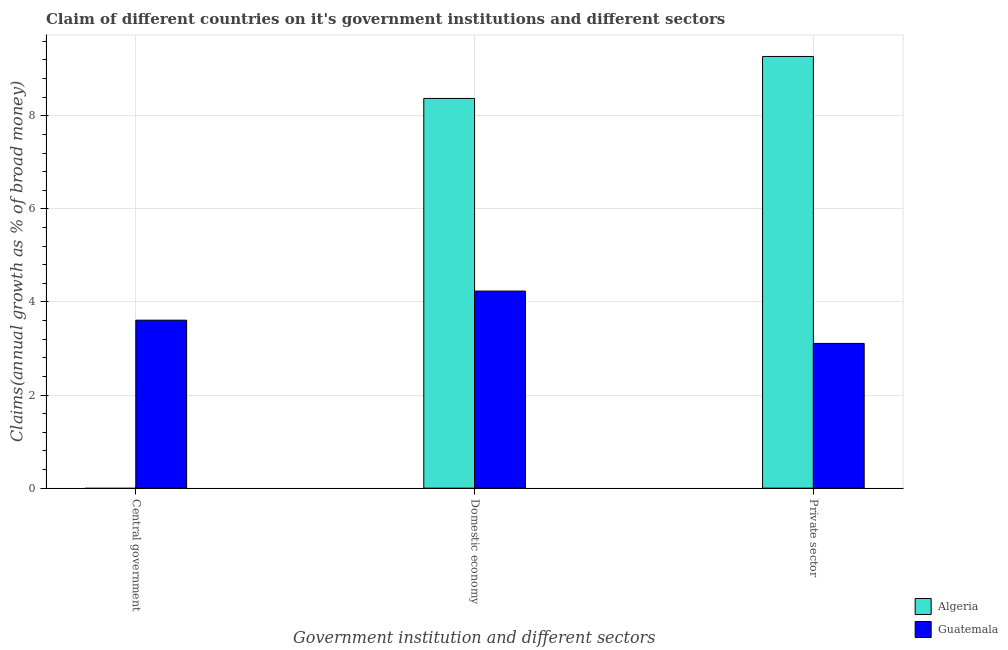Are the number of bars per tick equal to the number of legend labels?
Your answer should be compact. No. Are the number of bars on each tick of the X-axis equal?
Your answer should be compact. No. What is the label of the 1st group of bars from the left?
Give a very brief answer. Central government. What is the percentage of claim on the private sector in Guatemala?
Ensure brevity in your answer.  3.11. Across all countries, what is the maximum percentage of claim on the domestic economy?
Keep it short and to the point. 8.37. Across all countries, what is the minimum percentage of claim on the domestic economy?
Give a very brief answer. 4.23. In which country was the percentage of claim on the domestic economy maximum?
Offer a terse response. Algeria. What is the total percentage of claim on the private sector in the graph?
Your answer should be compact. 12.38. What is the difference between the percentage of claim on the domestic economy in Algeria and that in Guatemala?
Make the answer very short. 4.14. What is the difference between the percentage of claim on the domestic economy in Algeria and the percentage of claim on the central government in Guatemala?
Your answer should be compact. 4.76. What is the average percentage of claim on the central government per country?
Give a very brief answer. 1.8. What is the difference between the percentage of claim on the private sector and percentage of claim on the domestic economy in Algeria?
Your answer should be very brief. 0.9. In how many countries, is the percentage of claim on the private sector greater than 0.4 %?
Keep it short and to the point. 2. What is the ratio of the percentage of claim on the domestic economy in Algeria to that in Guatemala?
Your response must be concise. 1.98. Is the percentage of claim on the domestic economy in Algeria less than that in Guatemala?
Your response must be concise. No. What is the difference between the highest and the second highest percentage of claim on the private sector?
Give a very brief answer. 6.16. What is the difference between the highest and the lowest percentage of claim on the private sector?
Offer a terse response. 6.16. Is the sum of the percentage of claim on the domestic economy in Algeria and Guatemala greater than the maximum percentage of claim on the central government across all countries?
Offer a terse response. Yes. Is it the case that in every country, the sum of the percentage of claim on the central government and percentage of claim on the domestic economy is greater than the percentage of claim on the private sector?
Your answer should be compact. No. How many bars are there?
Offer a terse response. 5. Are the values on the major ticks of Y-axis written in scientific E-notation?
Offer a very short reply. No. Does the graph contain grids?
Offer a terse response. Yes. How many legend labels are there?
Provide a short and direct response. 2. What is the title of the graph?
Ensure brevity in your answer.  Claim of different countries on it's government institutions and different sectors. Does "Italy" appear as one of the legend labels in the graph?
Your answer should be compact. No. What is the label or title of the X-axis?
Keep it short and to the point. Government institution and different sectors. What is the label or title of the Y-axis?
Make the answer very short. Claims(annual growth as % of broad money). What is the Claims(annual growth as % of broad money) of Guatemala in Central government?
Provide a succinct answer. 3.61. What is the Claims(annual growth as % of broad money) in Algeria in Domestic economy?
Make the answer very short. 8.37. What is the Claims(annual growth as % of broad money) of Guatemala in Domestic economy?
Your answer should be very brief. 4.23. What is the Claims(annual growth as % of broad money) in Algeria in Private sector?
Provide a succinct answer. 9.27. What is the Claims(annual growth as % of broad money) in Guatemala in Private sector?
Make the answer very short. 3.11. Across all Government institution and different sectors, what is the maximum Claims(annual growth as % of broad money) in Algeria?
Offer a terse response. 9.27. Across all Government institution and different sectors, what is the maximum Claims(annual growth as % of broad money) of Guatemala?
Offer a terse response. 4.23. Across all Government institution and different sectors, what is the minimum Claims(annual growth as % of broad money) in Algeria?
Your answer should be compact. 0. Across all Government institution and different sectors, what is the minimum Claims(annual growth as % of broad money) of Guatemala?
Offer a terse response. 3.11. What is the total Claims(annual growth as % of broad money) of Algeria in the graph?
Offer a terse response. 17.65. What is the total Claims(annual growth as % of broad money) of Guatemala in the graph?
Provide a succinct answer. 10.95. What is the difference between the Claims(annual growth as % of broad money) in Guatemala in Central government and that in Domestic economy?
Offer a very short reply. -0.63. What is the difference between the Claims(annual growth as % of broad money) in Guatemala in Central government and that in Private sector?
Offer a very short reply. 0.5. What is the difference between the Claims(annual growth as % of broad money) of Algeria in Domestic economy and that in Private sector?
Provide a succinct answer. -0.9. What is the difference between the Claims(annual growth as % of broad money) of Guatemala in Domestic economy and that in Private sector?
Ensure brevity in your answer.  1.12. What is the difference between the Claims(annual growth as % of broad money) of Algeria in Domestic economy and the Claims(annual growth as % of broad money) of Guatemala in Private sector?
Your response must be concise. 5.26. What is the average Claims(annual growth as % of broad money) in Algeria per Government institution and different sectors?
Your answer should be compact. 5.88. What is the average Claims(annual growth as % of broad money) of Guatemala per Government institution and different sectors?
Give a very brief answer. 3.65. What is the difference between the Claims(annual growth as % of broad money) of Algeria and Claims(annual growth as % of broad money) of Guatemala in Domestic economy?
Your response must be concise. 4.14. What is the difference between the Claims(annual growth as % of broad money) in Algeria and Claims(annual growth as % of broad money) in Guatemala in Private sector?
Your answer should be very brief. 6.16. What is the ratio of the Claims(annual growth as % of broad money) in Guatemala in Central government to that in Domestic economy?
Your answer should be compact. 0.85. What is the ratio of the Claims(annual growth as % of broad money) of Guatemala in Central government to that in Private sector?
Make the answer very short. 1.16. What is the ratio of the Claims(annual growth as % of broad money) in Algeria in Domestic economy to that in Private sector?
Your answer should be compact. 0.9. What is the ratio of the Claims(annual growth as % of broad money) in Guatemala in Domestic economy to that in Private sector?
Your response must be concise. 1.36. What is the difference between the highest and the second highest Claims(annual growth as % of broad money) in Guatemala?
Keep it short and to the point. 0.63. What is the difference between the highest and the lowest Claims(annual growth as % of broad money) of Algeria?
Keep it short and to the point. 9.27. What is the difference between the highest and the lowest Claims(annual growth as % of broad money) in Guatemala?
Ensure brevity in your answer.  1.12. 